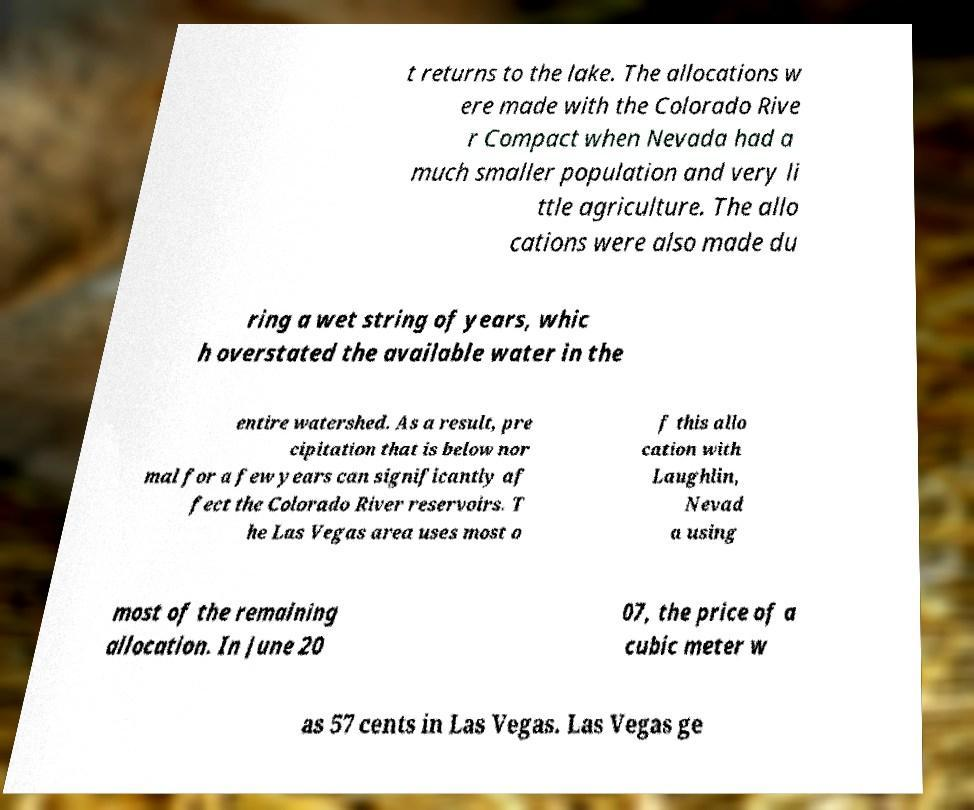Please identify and transcribe the text found in this image. t returns to the lake. The allocations w ere made with the Colorado Rive r Compact when Nevada had a much smaller population and very li ttle agriculture. The allo cations were also made du ring a wet string of years, whic h overstated the available water in the entire watershed. As a result, pre cipitation that is below nor mal for a few years can significantly af fect the Colorado River reservoirs. T he Las Vegas area uses most o f this allo cation with Laughlin, Nevad a using most of the remaining allocation. In June 20 07, the price of a cubic meter w as 57 cents in Las Vegas. Las Vegas ge 